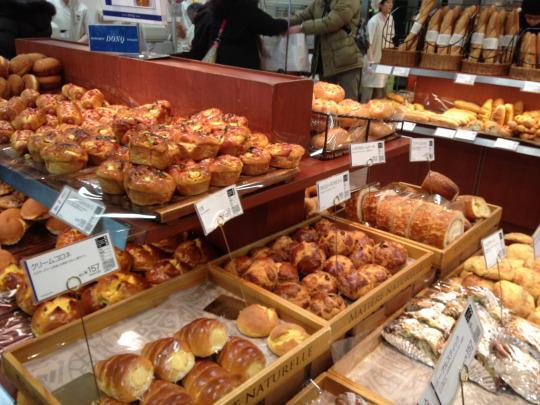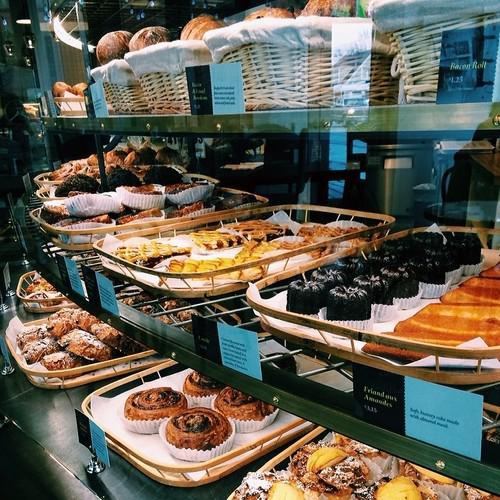The first image is the image on the left, the second image is the image on the right. Evaluate the accuracy of this statement regarding the images: "there is a person in one of the images". Is it true? Answer yes or no. No. 